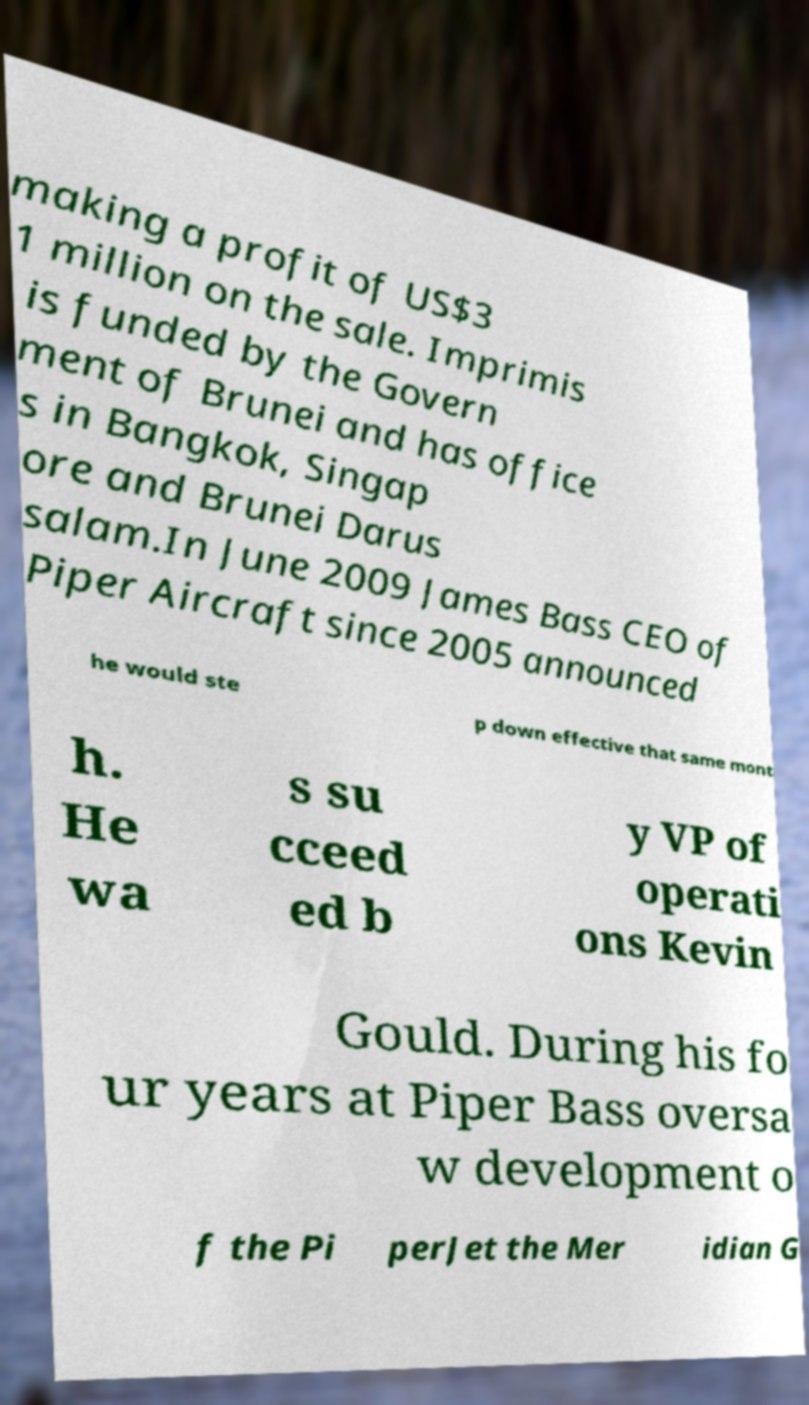For documentation purposes, I need the text within this image transcribed. Could you provide that? making a profit of US$3 1 million on the sale. Imprimis is funded by the Govern ment of Brunei and has office s in Bangkok, Singap ore and Brunei Darus salam.In June 2009 James Bass CEO of Piper Aircraft since 2005 announced he would ste p down effective that same mont h. He wa s su cceed ed b y VP of operati ons Kevin Gould. During his fo ur years at Piper Bass oversa w development o f the Pi perJet the Mer idian G 